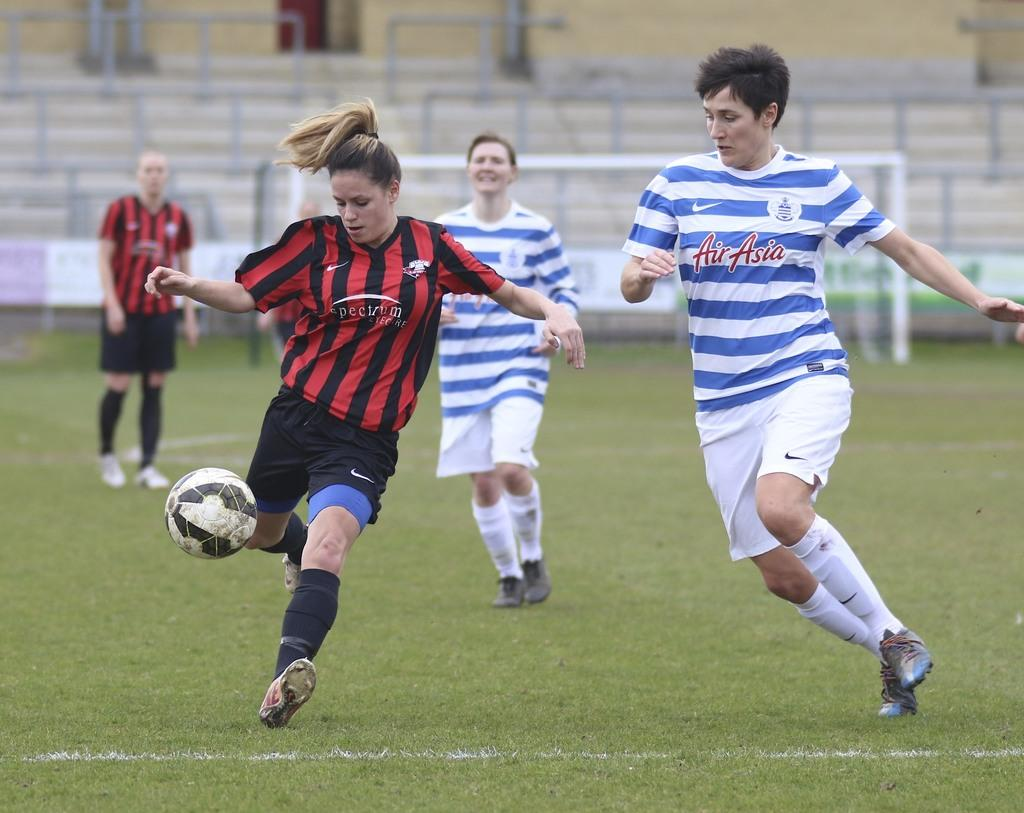How many people are playing football in the image? There are four persons in the image. What are the persons doing in the image? The persons are playing football. What is the surface they are playing on? The ground is covered with grass. What can be seen in the background of the image? There is a mesh in the background of the image. What type of creature is seen forming a circle in the image? There is no creature forming a circle in the image; it features four persons playing football on a grassy surface with a mesh in the background. 